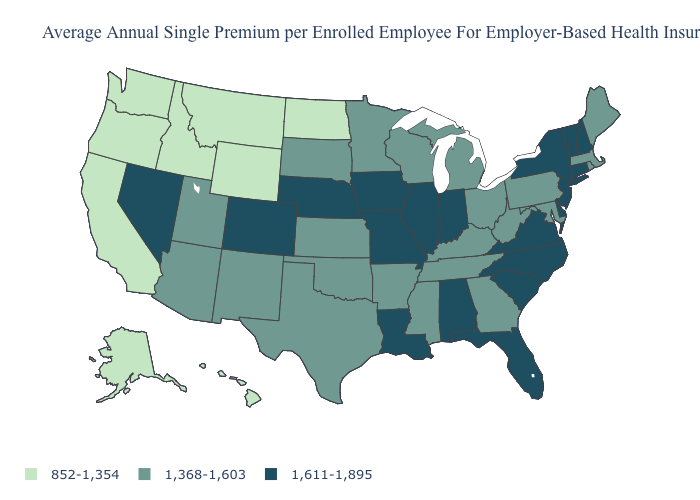Which states have the lowest value in the Northeast?
Keep it brief. Maine, Massachusetts, Pennsylvania, Rhode Island. Which states have the lowest value in the MidWest?
Answer briefly. North Dakota. Among the states that border Ohio , does Indiana have the lowest value?
Short answer required. No. What is the value of New Jersey?
Be succinct. 1,611-1,895. Which states have the lowest value in the South?
Write a very short answer. Arkansas, Georgia, Kentucky, Maryland, Mississippi, Oklahoma, Tennessee, Texas, West Virginia. What is the highest value in the USA?
Be succinct. 1,611-1,895. What is the value of Maryland?
Short answer required. 1,368-1,603. Does New Jersey have the same value as Washington?
Write a very short answer. No. What is the highest value in the USA?
Write a very short answer. 1,611-1,895. What is the value of Michigan?
Quick response, please. 1,368-1,603. What is the value of Connecticut?
Short answer required. 1,611-1,895. Among the states that border Nevada , which have the lowest value?
Answer briefly. California, Idaho, Oregon. Does Indiana have the lowest value in the MidWest?
Answer briefly. No. Which states have the highest value in the USA?
Concise answer only. Alabama, Colorado, Connecticut, Delaware, Florida, Illinois, Indiana, Iowa, Louisiana, Missouri, Nebraska, Nevada, New Hampshire, New Jersey, New York, North Carolina, South Carolina, Vermont, Virginia. Does Missouri have the highest value in the MidWest?
Short answer required. Yes. 